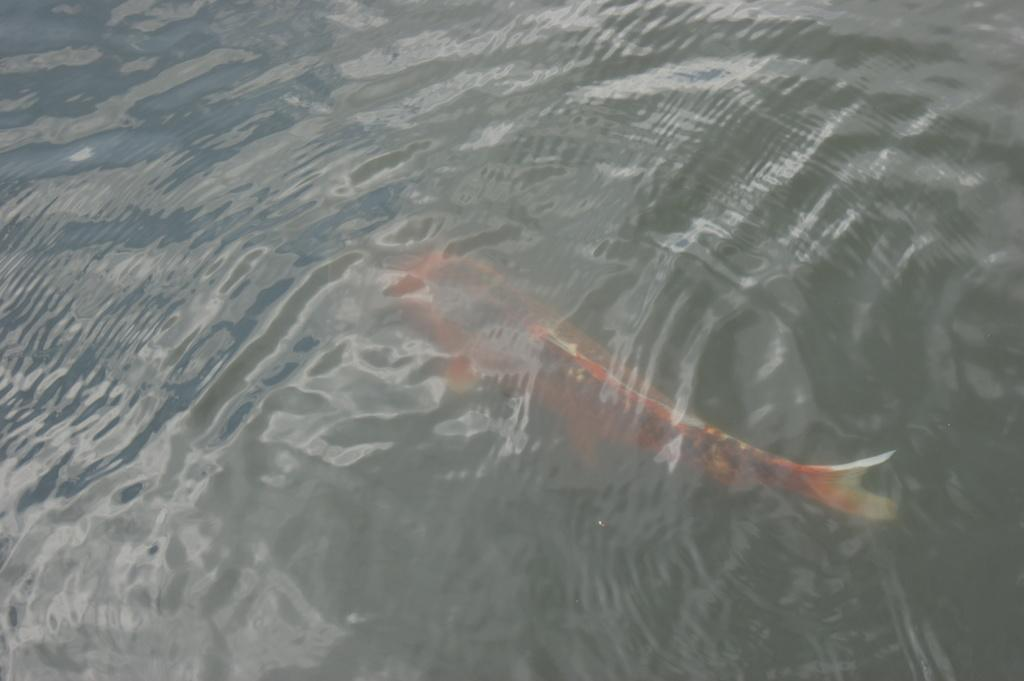What type of animal is in the image? There is a fish in the image. Where is the fish located in relation to the water? The fish is under the water. How close is the fish to the viewer in the image? The fish is in the foreground of the image. What type of teeth can be seen on the boat in the image? There is no boat present in the image, and therefore no teeth can be seen on a boat. 